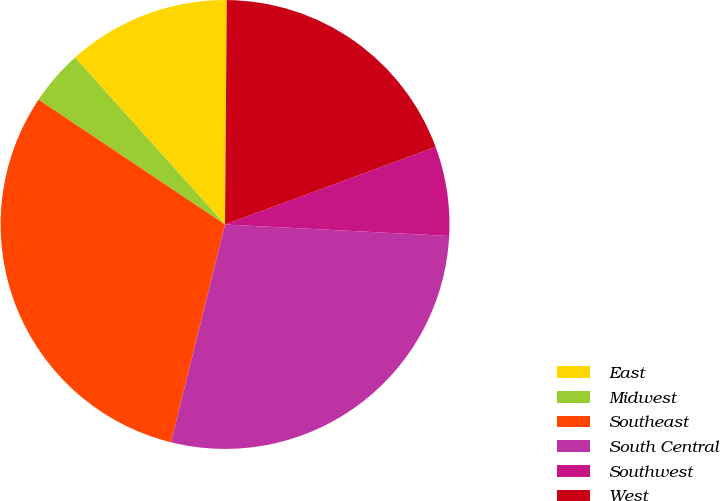<chart> <loc_0><loc_0><loc_500><loc_500><pie_chart><fcel>East<fcel>Midwest<fcel>Southeast<fcel>South Central<fcel>Southwest<fcel>West<nl><fcel>11.77%<fcel>3.96%<fcel>30.52%<fcel>28.05%<fcel>6.43%<fcel>19.26%<nl></chart> 